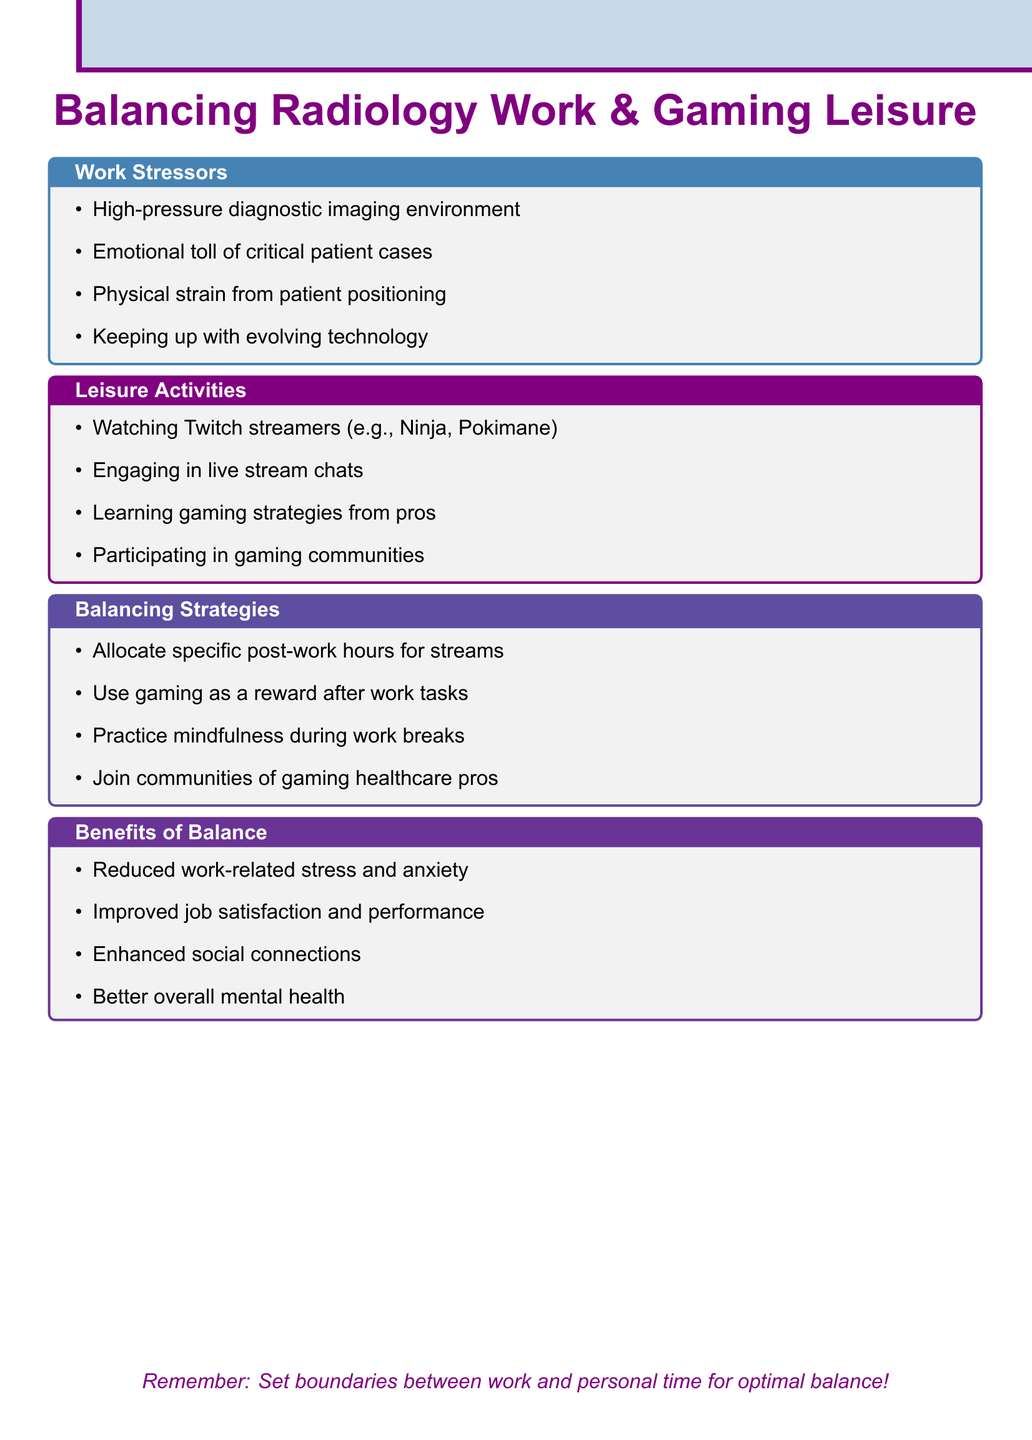What is the title of the notes? The title is explicitly stated at the beginning of the document as a key heading.
Answer: Balancing Radiology Work Stress and Gaming Leisure Which gaming platforms are mentioned? The document lists the primary platforms for streaming as part of leisure activities.
Answer: Twitch and YouTube Gaming What is one work stressor related to patient cases? The document specifies a particular emotional challenge experienced by technicians.
Answer: Emotional toll of dealing with critical patient cases Name a popular Twitch streamer mentioned. The document includes examples of streamers watched for entertainment.
Answer: Ninja What is a strategy for balancing work and leisure? The document outlines specific approaches to manage the time between work and leisure activities.
Answer: Allocating specific post-work hours for gaming stream consumption How does balance benefit mental health? The document highlights general improvements in mental health as a benefit of balance.
Answer: Better overall mental health What is one way to engage during gaming streams? The document describes an interactive aspect of the leisure activity that fosters connection.
Answer: Engaging in chat during live streams Which community platforms are mentioned for gaming? The document identifies online communities where gamers, including healthcare professionals, interact.
Answer: Discord or Reddit What is a physical strain mentioned related to work? The document discusses the physical demands placed on technicians in their work environment.
Answer: Physical strain from positioning patients 